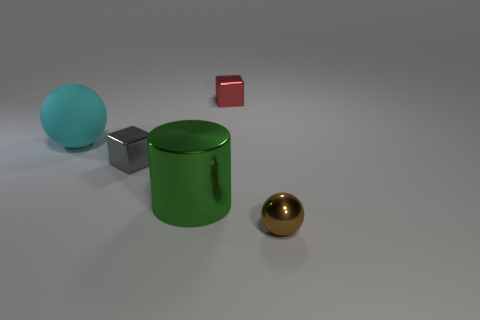Subtract all red balls. Subtract all green cylinders. How many balls are left? 2 Add 1 gray objects. How many objects exist? 6 Subtract all cylinders. How many objects are left? 4 Add 2 large matte things. How many large matte things are left? 3 Add 5 small gray balls. How many small gray balls exist? 5 Subtract 0 purple spheres. How many objects are left? 5 Subtract all big cyan metallic cylinders. Subtract all shiny cylinders. How many objects are left? 4 